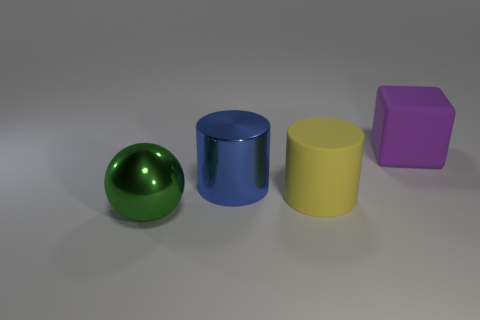Are there any rubber blocks behind the cylinder in front of the large metallic object that is behind the large green ball? Yes, there is one rubber block located behind the cylinder. Specifically, it's the purple block situated behind the blue cylinder, which is in turn in front of what appears to be a large metallic sphere, not far from the green ball. 